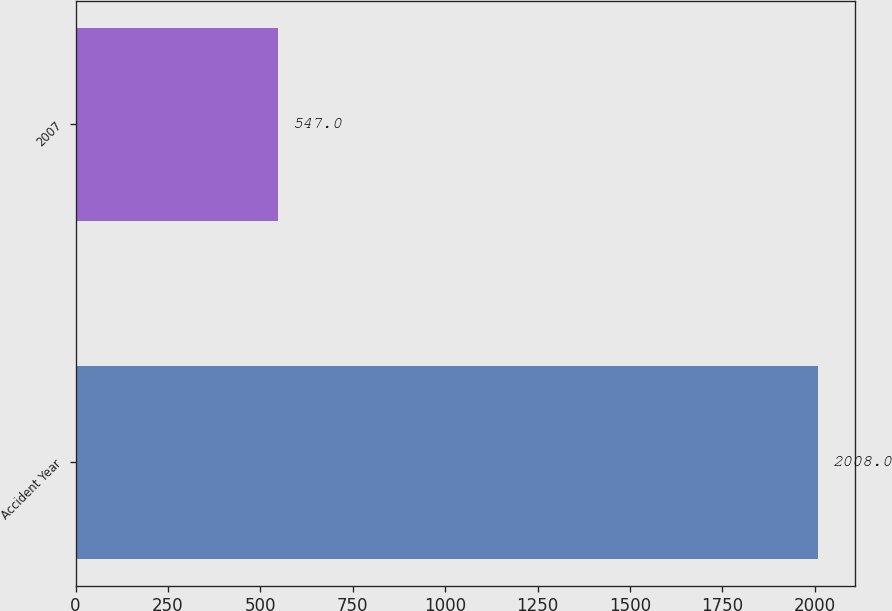Convert chart. <chart><loc_0><loc_0><loc_500><loc_500><bar_chart><fcel>Accident Year<fcel>2007<nl><fcel>2008<fcel>547<nl></chart> 